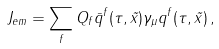<formula> <loc_0><loc_0><loc_500><loc_500>J _ { e m } = \sum _ { f } Q _ { f } \bar { q } ^ { f } ( \tau , \vec { x } ) \gamma _ { \mu } q ^ { f } ( \tau , \vec { x } ) \, ,</formula> 